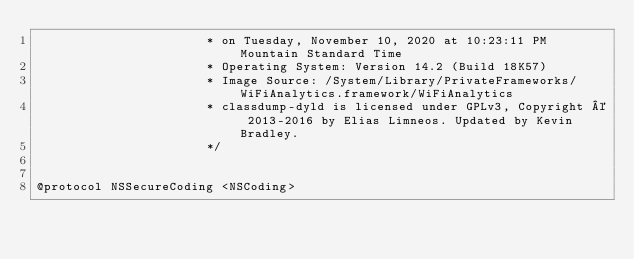<code> <loc_0><loc_0><loc_500><loc_500><_C_>                       * on Tuesday, November 10, 2020 at 10:23:11 PM Mountain Standard Time
                       * Operating System: Version 14.2 (Build 18K57)
                       * Image Source: /System/Library/PrivateFrameworks/WiFiAnalytics.framework/WiFiAnalytics
                       * classdump-dyld is licensed under GPLv3, Copyright © 2013-2016 by Elias Limneos. Updated by Kevin Bradley.
                       */


@protocol NSSecureCoding <NSCoding></code> 